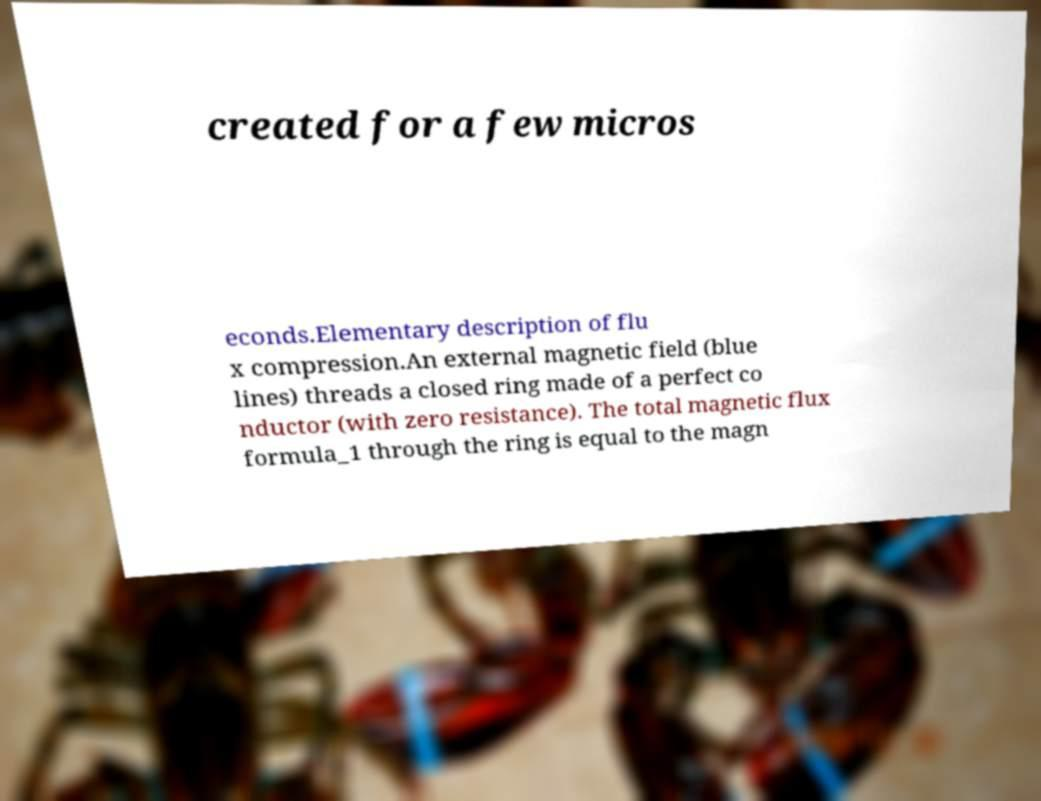Please identify and transcribe the text found in this image. created for a few micros econds.Elementary description of flu x compression.An external magnetic field (blue lines) threads a closed ring made of a perfect co nductor (with zero resistance). The total magnetic flux formula_1 through the ring is equal to the magn 